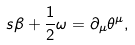<formula> <loc_0><loc_0><loc_500><loc_500>s \beta + \frac { 1 } { 2 } \omega = \partial _ { \mu } \theta ^ { \mu } ,</formula> 